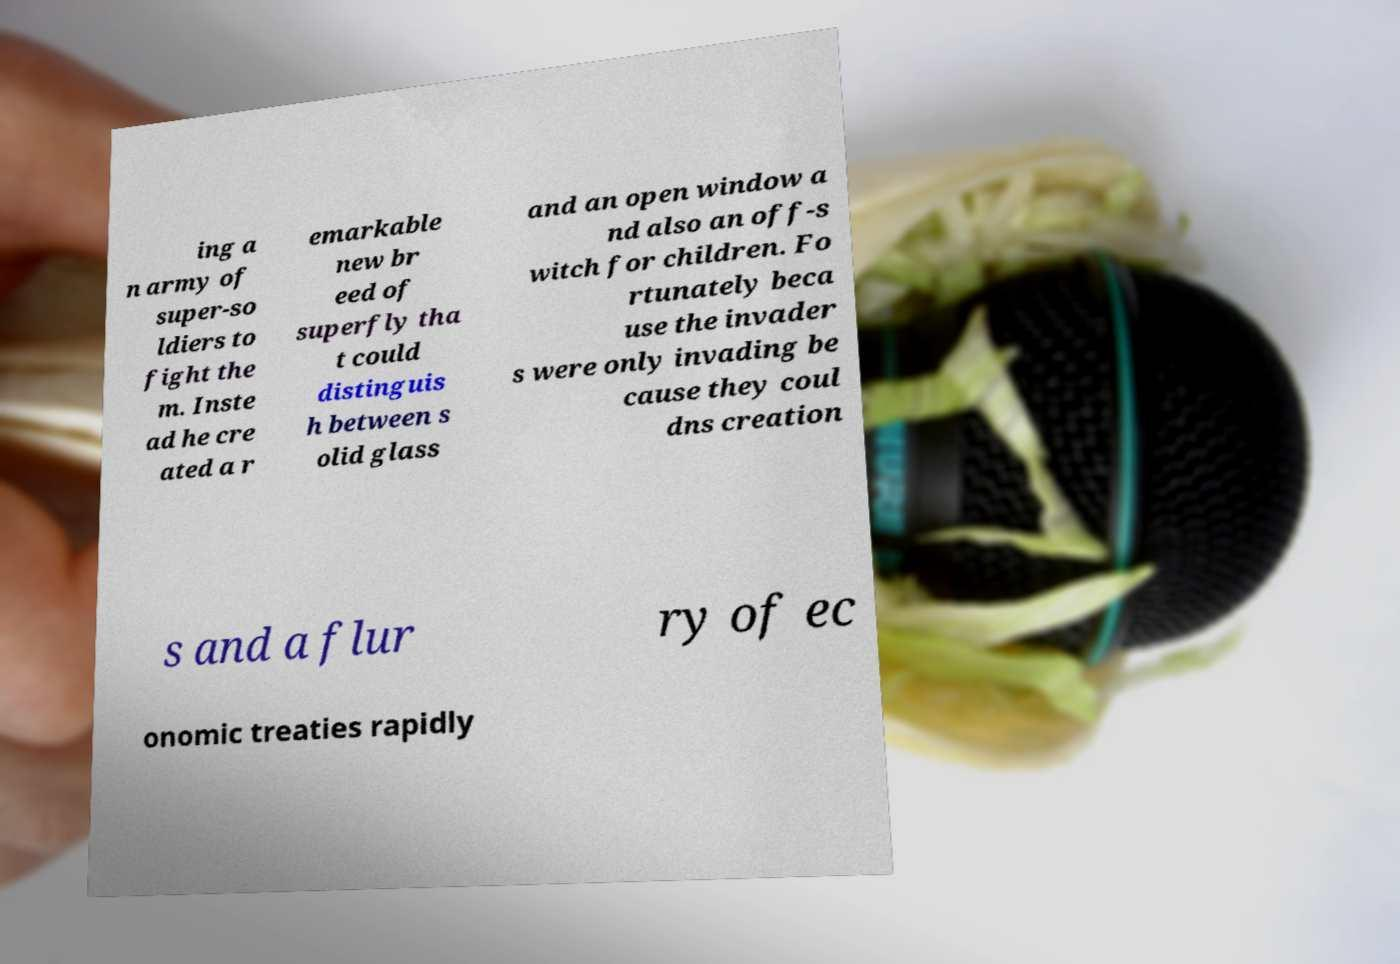For documentation purposes, I need the text within this image transcribed. Could you provide that? ing a n army of super-so ldiers to fight the m. Inste ad he cre ated a r emarkable new br eed of superfly tha t could distinguis h between s olid glass and an open window a nd also an off-s witch for children. Fo rtunately beca use the invader s were only invading be cause they coul dns creation s and a flur ry of ec onomic treaties rapidly 